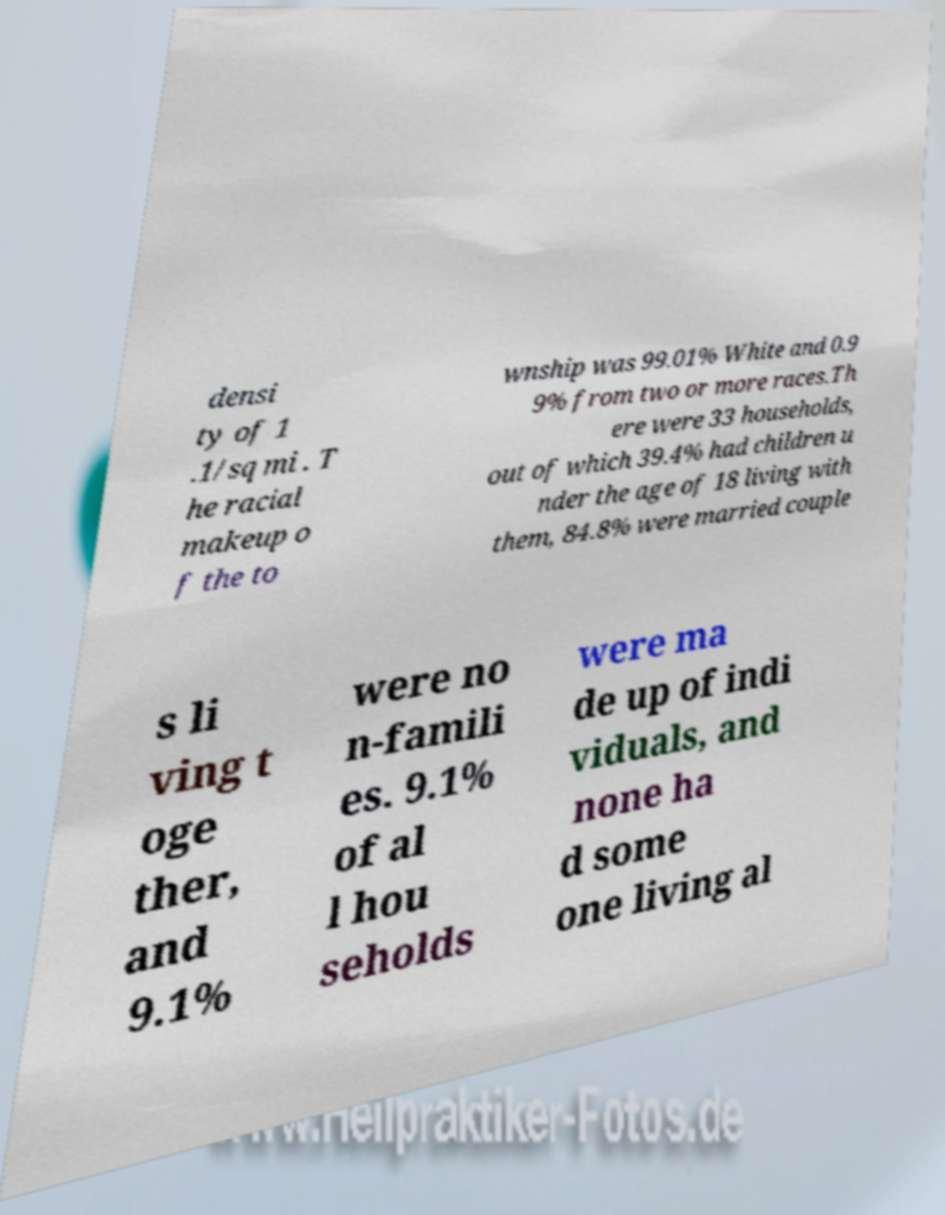What messages or text are displayed in this image? I need them in a readable, typed format. densi ty of 1 .1/sq mi . T he racial makeup o f the to wnship was 99.01% White and 0.9 9% from two or more races.Th ere were 33 households, out of which 39.4% had children u nder the age of 18 living with them, 84.8% were married couple s li ving t oge ther, and 9.1% were no n-famili es. 9.1% of al l hou seholds were ma de up of indi viduals, and none ha d some one living al 